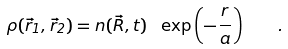<formula> <loc_0><loc_0><loc_500><loc_500>\rho ( \vec { r } _ { 1 } , \vec { r } _ { 2 } ) = n ( \vec { R } , t ) \ \exp \left ( - \frac { r } { a } \right ) \quad .</formula> 